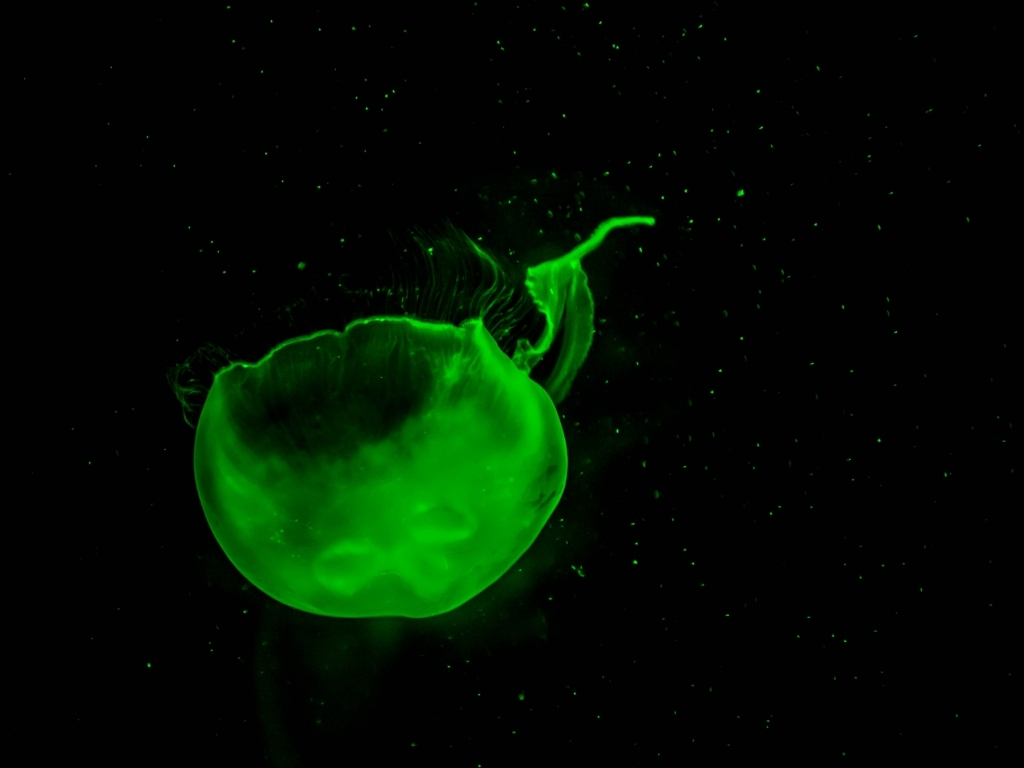What is the overall quality of the image?
A. Excellent
B. Average
C. Poor
D. Exceptional While the image has a certain visual appeal with its vivid green color and contrasting dark background, there is noticeable noise and lack of sharpness which might be due to the conditions of the shot or the limitations of the equipment used. This could detract from the image's perceived quality for professional purposes. Hence, I would rate it as 'B. Average', recognizing both its strengths and areas for improvement. 